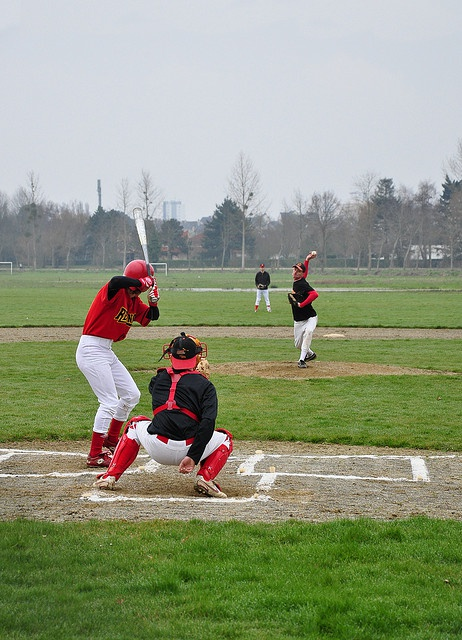Describe the objects in this image and their specific colors. I can see people in lightgray, black, brown, and darkgray tones, people in lightgray, lavender, brown, maroon, and black tones, people in lightgray, black, darkgray, and gray tones, baseball bat in lightgray, darkgray, and gray tones, and people in lightgray, black, lavender, darkgray, and gray tones in this image. 